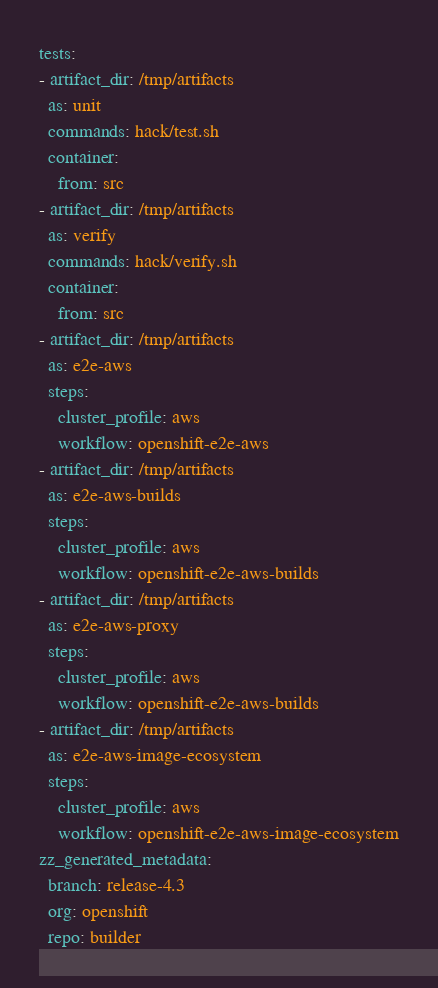<code> <loc_0><loc_0><loc_500><loc_500><_YAML_>tests:
- artifact_dir: /tmp/artifacts
  as: unit
  commands: hack/test.sh
  container:
    from: src
- artifact_dir: /tmp/artifacts
  as: verify
  commands: hack/verify.sh
  container:
    from: src
- artifact_dir: /tmp/artifacts
  as: e2e-aws
  steps:
    cluster_profile: aws
    workflow: openshift-e2e-aws
- artifact_dir: /tmp/artifacts
  as: e2e-aws-builds
  steps:
    cluster_profile: aws
    workflow: openshift-e2e-aws-builds
- artifact_dir: /tmp/artifacts
  as: e2e-aws-proxy
  steps:
    cluster_profile: aws
    workflow: openshift-e2e-aws-builds
- artifact_dir: /tmp/artifacts
  as: e2e-aws-image-ecosystem
  steps:
    cluster_profile: aws
    workflow: openshift-e2e-aws-image-ecosystem
zz_generated_metadata:
  branch: release-4.3
  org: openshift
  repo: builder
</code> 